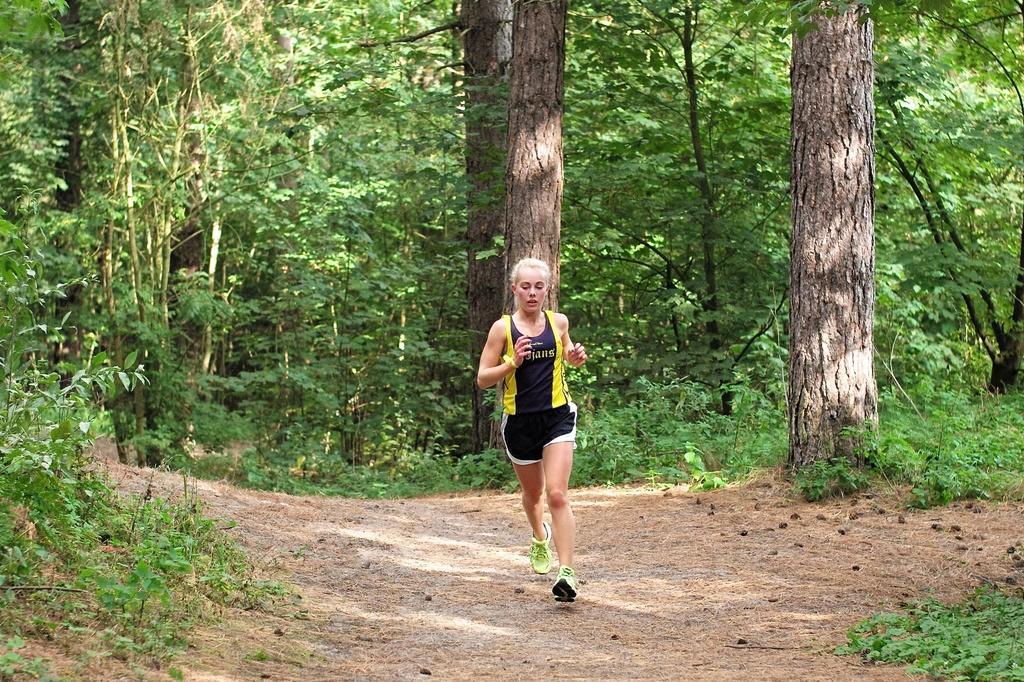Describe this image in one or two sentences. In this image, we can see a lady wearing a T-shirt and shorts. We can see the ground. We can see some plants, grass and trees. 